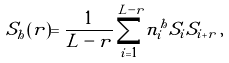Convert formula to latex. <formula><loc_0><loc_0><loc_500><loc_500>S _ { h } ( r ) = \frac { 1 } { L - r } \sum _ { i = 1 } ^ { L - r } n ^ { h } _ { i } S _ { i } S _ { i + r } \, ,</formula> 